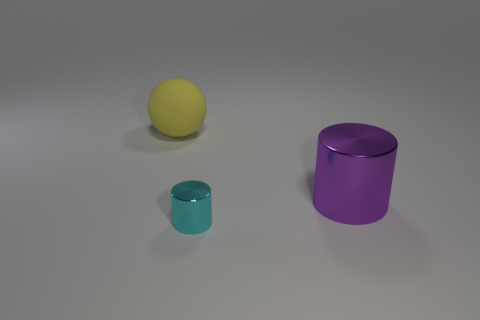What is the shape of the large thing that is on the right side of the big object on the left side of the large thing to the right of the big rubber ball?
Your response must be concise. Cylinder. There is a tiny thing; how many big yellow things are to the left of it?
Provide a succinct answer. 1. Is the material of the big thing behind the large purple thing the same as the cyan object?
Ensure brevity in your answer.  No. How many other things are there of the same shape as the yellow object?
Offer a very short reply. 0. What number of small cyan objects are on the left side of the object that is on the left side of the metallic cylinder that is on the left side of the big purple cylinder?
Your answer should be compact. 0. What color is the metallic cylinder that is to the left of the large purple metal thing?
Make the answer very short. Cyan. What is the size of the other shiny object that is the same shape as the purple shiny object?
Give a very brief answer. Small. Are there any other things that have the same size as the cyan metallic cylinder?
Your response must be concise. No. What is the material of the large thing in front of the thing that is behind the big object that is in front of the yellow rubber object?
Make the answer very short. Metal. Is the number of cyan objects on the right side of the cyan thing greater than the number of objects right of the yellow rubber sphere?
Offer a very short reply. No. 